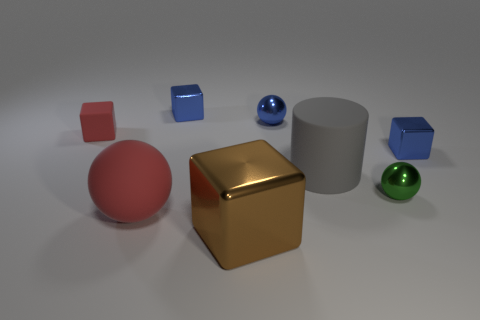Subtract all red balls. How many balls are left? 2 Subtract all blue cylinders. How many blue cubes are left? 2 Add 1 big brown objects. How many objects exist? 9 Subtract all green spheres. How many spheres are left? 2 Subtract 1 cubes. How many cubes are left? 3 Subtract all cylinders. How many objects are left? 7 Subtract 1 brown cubes. How many objects are left? 7 Subtract all red cylinders. Subtract all purple blocks. How many cylinders are left? 1 Subtract all tiny red metallic cylinders. Subtract all rubber cylinders. How many objects are left? 7 Add 5 rubber objects. How many rubber objects are left? 8 